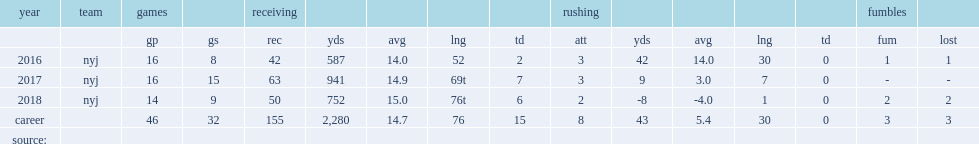How many receptions did robby anderson get in 2016? 42.0. 